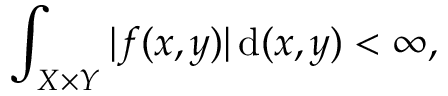Convert formula to latex. <formula><loc_0><loc_0><loc_500><loc_500>\int _ { X \times Y } | f ( x , y ) | \, { d } ( x , y ) < \infty ,</formula> 